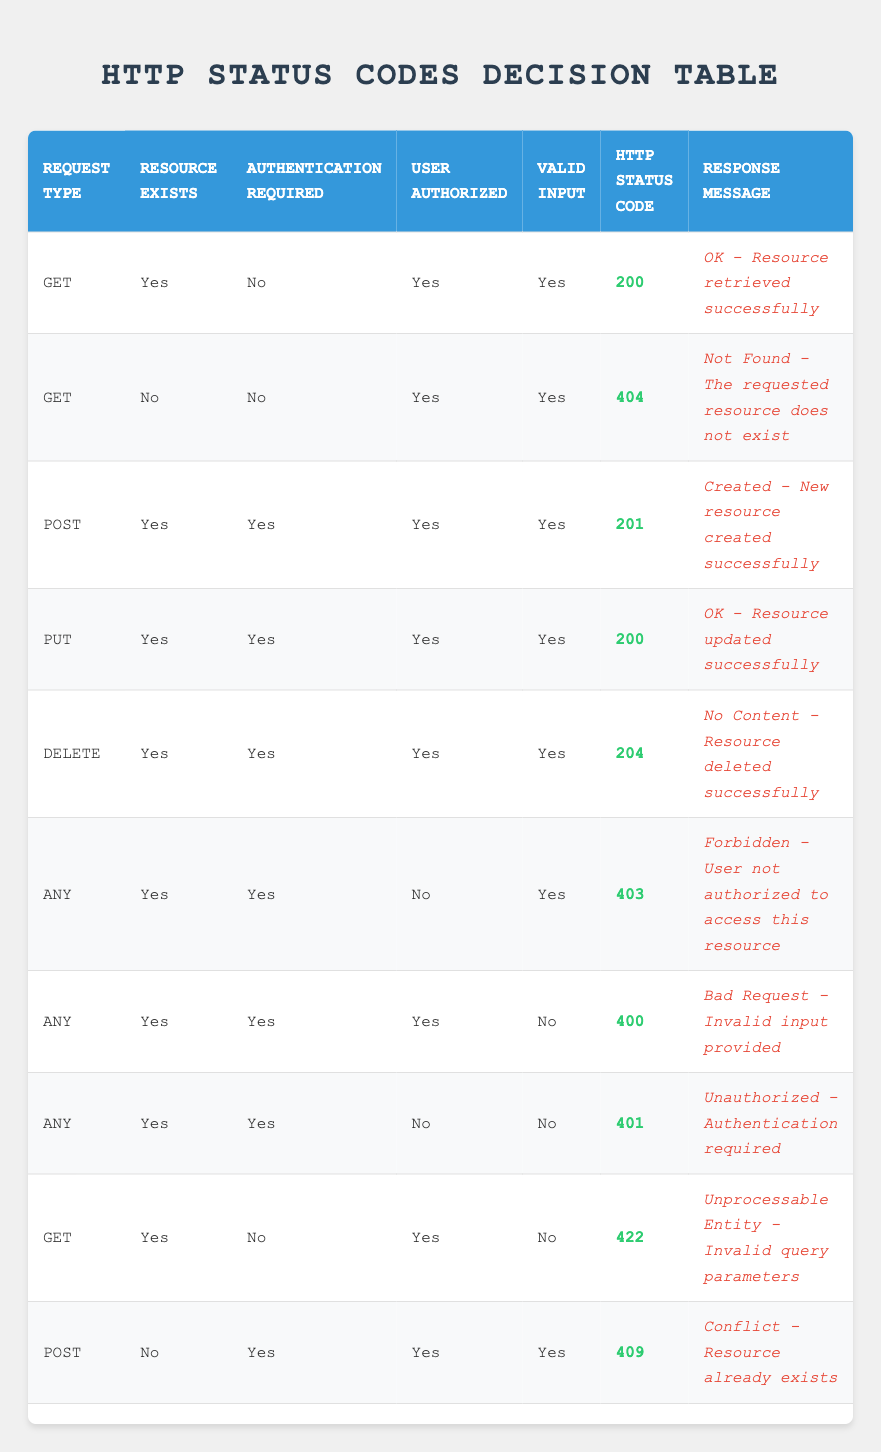What HTTP status code is returned for a GET request with an existing resource? According to the table, when a GET request is made and the resource exists, the corresponding HTTP status code is 200. This is indicated in the first rule of the table.
Answer: 200 What is the response message for a POST request that leads to a conflict? The table shows that when a POST request is made for a resource that does not exist and is being created, it results in a status code of 409 with the response message "Conflict - Resource already exists". This is detailed in the last rule regarding POST requests.
Answer: Conflict - Resource already exists Is authentication required for a DELETE request when the user is authorized? Based on the table data, a DELETE request requires authentication if the user is authorized, which is confirmed in the row with the DELETE request type showing all required conditions as true.
Answer: Yes How many unique HTTP status codes are represented in the table? To find the unique status codes, we review the table's last column. The unique codes recorded are 200, 201, 204, 400, 401, 403, 404, 409, and 422. Counting these unique codes, we arrive at a total of 9 distinct status codes present in the table.
Answer: 9 What response message would be given for an invalid GET request due to unacceptable query parameters? The table specifies in the row for a GET request with an existing resource where the query parameters are invalid (valid input is false), which corresponds to the code 422. The response message in this case is "Unprocessable Entity - Invalid query parameters."
Answer: Unprocessable Entity - Invalid query parameters If a PUT request fails because of an invalid input, will it return a 200 status code? The table clearly outlines that for a PUT request to return a 200 status code, all conditions including valid input must be true. If valid input is false, it doesn’t return 200, so the statement is false.
Answer: No What is the status code for a successful resource deletion? Looking at the DELETE request scenario where all conditions are satisfied (resource exists, authentication required, user is authorized, valid input), the resulting status code is 204, as indicated in the table.
Answer: 204 Are the rules about user authorization consistent across all request types? The table illustrates that user authorization only impacts certain request types, especially when it varies between allowed and restricted access, as seen in the 403 and 401 response cases. Thus, it can be concluded that the rules are not consistent across all request types.
Answer: No What happens if an unauthorized user tries to access a resource that exists? Reviewing the table, if an unauthorized user attempts to access an existing resource (as per the rules defined for any request type), the appropriate status code returned would be 403, highlighted in the corresponding row.
Answer: 403 